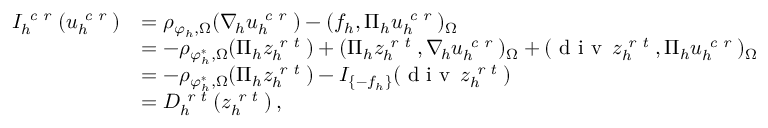Convert formula to latex. <formula><loc_0><loc_0><loc_500><loc_500>\begin{array} { r l } { I _ { h } ^ { c r } ( u _ { h } ^ { c r } ) } & { = \rho _ { \varphi _ { h } , \Omega } ( \nabla _ { \, h } u _ { h } ^ { c r } ) - ( f _ { h } , \Pi _ { h } u _ { h } ^ { c r } ) _ { \Omega } } \\ & { = - \rho _ { \varphi _ { h } ^ { * } , \Omega } ( \Pi _ { h } z _ { h } ^ { r t } ) + ( \Pi _ { h } z _ { h } ^ { r t } , \nabla _ { \, h } u _ { h } ^ { c r } ) _ { \Omega } + ( d i v \, z _ { h } ^ { r t } , \Pi _ { h } u _ { h } ^ { c r } ) _ { \Omega } } \\ & { = - \rho _ { \varphi _ { h } ^ { * } , \Omega } ( \Pi _ { h } z _ { h } ^ { r t } ) - I _ { \{ - f _ { h } \} } ( d i v \, z _ { h } ^ { r t } ) } \\ & { = D _ { h } ^ { r t } ( z _ { h } ^ { r t } ) \, , } \end{array}</formula> 